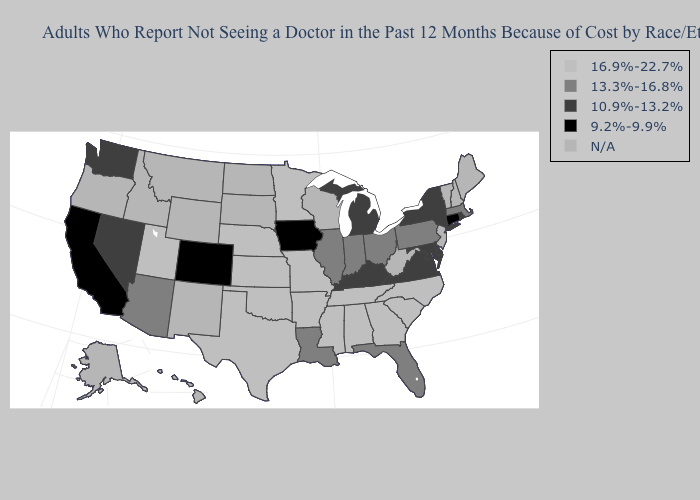Name the states that have a value in the range 9.2%-9.9%?
Be succinct. California, Colorado, Connecticut, Iowa. Does Arizona have the lowest value in the West?
Answer briefly. No. Among the states that border Alabama , which have the lowest value?
Write a very short answer. Florida. Among the states that border North Carolina , which have the lowest value?
Concise answer only. Virginia. How many symbols are there in the legend?
Quick response, please. 5. Which states have the lowest value in the West?
Give a very brief answer. California, Colorado. What is the highest value in the West ?
Give a very brief answer. 16.9%-22.7%. Is the legend a continuous bar?
Short answer required. No. Name the states that have a value in the range 13.3%-16.8%?
Be succinct. Arizona, Florida, Illinois, Indiana, Louisiana, Massachusetts, Ohio, Pennsylvania. Name the states that have a value in the range N/A?
Quick response, please. Alaska, Hawaii, Idaho, Maine, Montana, New Hampshire, New Jersey, New Mexico, North Dakota, Oregon, South Dakota, Vermont, West Virginia, Wisconsin, Wyoming. What is the highest value in the USA?
Quick response, please. 16.9%-22.7%. What is the lowest value in states that border Utah?
Give a very brief answer. 9.2%-9.9%. 